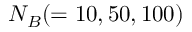Convert formula to latex. <formula><loc_0><loc_0><loc_500><loc_500>N _ { B } ( = 1 0 , 5 0 , 1 0 0 )</formula> 